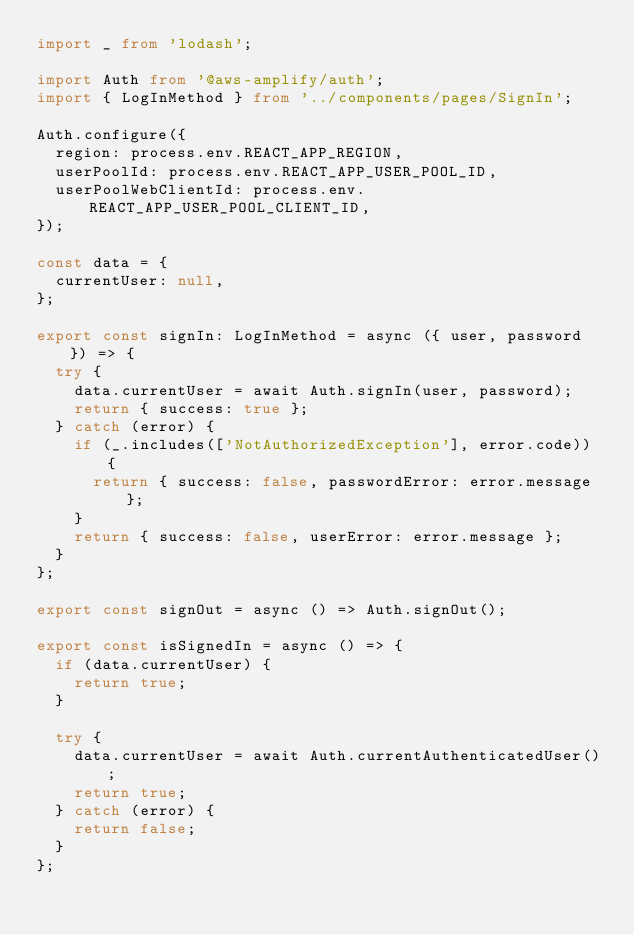<code> <loc_0><loc_0><loc_500><loc_500><_TypeScript_>import _ from 'lodash';

import Auth from '@aws-amplify/auth';
import { LogInMethod } from '../components/pages/SignIn';

Auth.configure({
  region: process.env.REACT_APP_REGION,
  userPoolId: process.env.REACT_APP_USER_POOL_ID,
  userPoolWebClientId: process.env.REACT_APP_USER_POOL_CLIENT_ID,
});

const data = {
  currentUser: null,
};

export const signIn: LogInMethod = async ({ user, password }) => {
  try {
    data.currentUser = await Auth.signIn(user, password);
    return { success: true };
  } catch (error) {
    if (_.includes(['NotAuthorizedException'], error.code)) {
      return { success: false, passwordError: error.message };
    }
    return { success: false, userError: error.message };
  }
};

export const signOut = async () => Auth.signOut();

export const isSignedIn = async () => {
  if (data.currentUser) {
    return true;
  }

  try {
    data.currentUser = await Auth.currentAuthenticatedUser();
    return true;
  } catch (error) {
    return false;
  }
};
</code> 